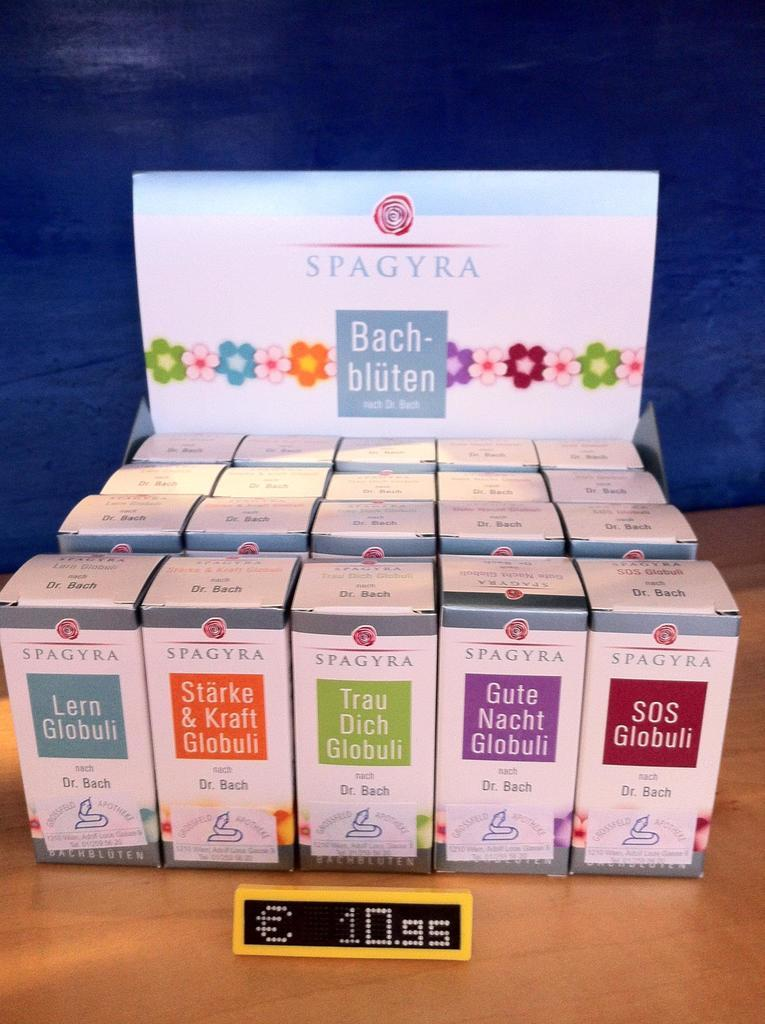<image>
Render a clear and concise summary of the photo. A bunch of boxes  from Spagyra with a foreigner language on the front. 